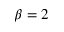Convert formula to latex. <formula><loc_0><loc_0><loc_500><loc_500>\beta = 2</formula> 